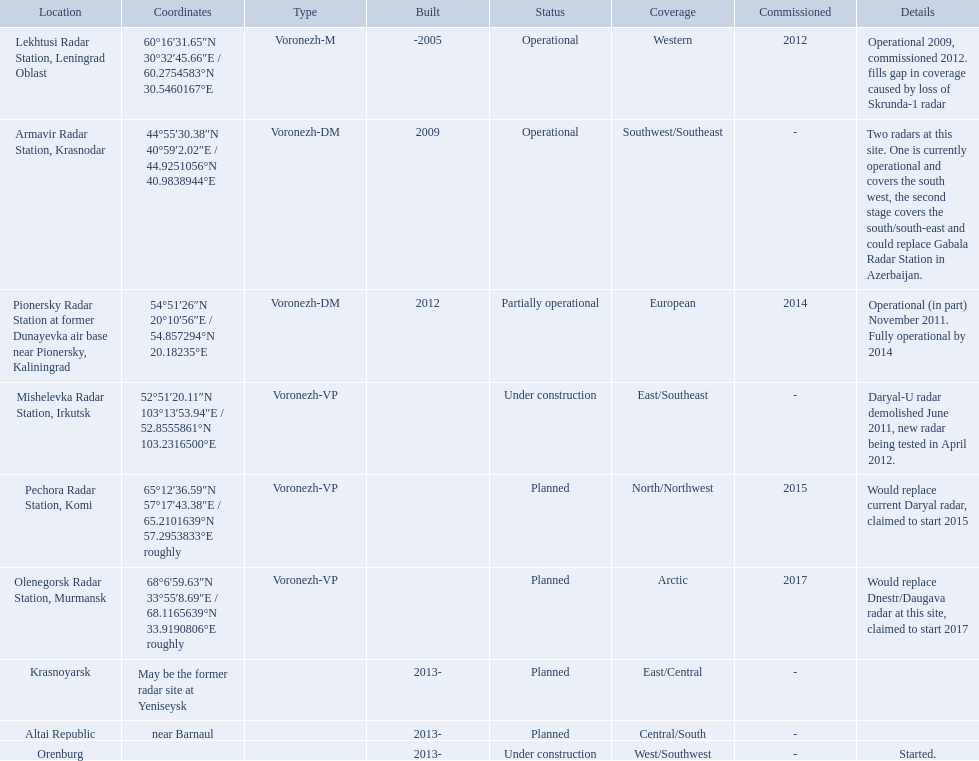Which voronezh radar has already started? Orenburg. Which radar would replace dnestr/daugava? Olenegorsk Radar Station, Murmansk. Which radar started in 2015? Pechora Radar Station, Komi. Where is each radar? Lekhtusi Radar Station, Leningrad Oblast, Armavir Radar Station, Krasnodar, Pionersky Radar Station at former Dunayevka air base near Pionersky, Kaliningrad, Mishelevka Radar Station, Irkutsk, Pechora Radar Station, Komi, Olenegorsk Radar Station, Murmansk, Krasnoyarsk, Altai Republic, Orenburg. What are the details of each radar? Operational 2009, commissioned 2012. fills gap in coverage caused by loss of Skrunda-1 radar, Two radars at this site. One is currently operational and covers the south west, the second stage covers the south/south-east and could replace Gabala Radar Station in Azerbaijan., Operational (in part) November 2011. Fully operational by 2014, Daryal-U radar demolished June 2011, new radar being tested in April 2012., Would replace current Daryal radar, claimed to start 2015, Would replace Dnestr/Daugava radar at this site, claimed to start 2017, , , Started. Which radar is detailed to start in 2015? Pechora Radar Station, Komi. Which column has the coordinates starting with 60 deg? 60°16′31.65″N 30°32′45.66″E﻿ / ﻿60.2754583°N 30.5460167°E. What is the location in the same row as that column? Lekhtusi Radar Station, Leningrad Oblast. Voronezh radar has locations where? Lekhtusi Radar Station, Leningrad Oblast, Armavir Radar Station, Krasnodar, Pionersky Radar Station at former Dunayevka air base near Pionersky, Kaliningrad, Mishelevka Radar Station, Irkutsk, Pechora Radar Station, Komi, Olenegorsk Radar Station, Murmansk, Krasnoyarsk, Altai Republic, Orenburg. Which of these locations have know coordinates? Lekhtusi Radar Station, Leningrad Oblast, Armavir Radar Station, Krasnodar, Pionersky Radar Station at former Dunayevka air base near Pionersky, Kaliningrad, Mishelevka Radar Station, Irkutsk, Pechora Radar Station, Komi, Olenegorsk Radar Station, Murmansk. Which of these locations has coordinates of 60deg16'31.65''n 30deg32'45.66''e / 60.2754583degn 30.5460167dege? Lekhtusi Radar Station, Leningrad Oblast. 